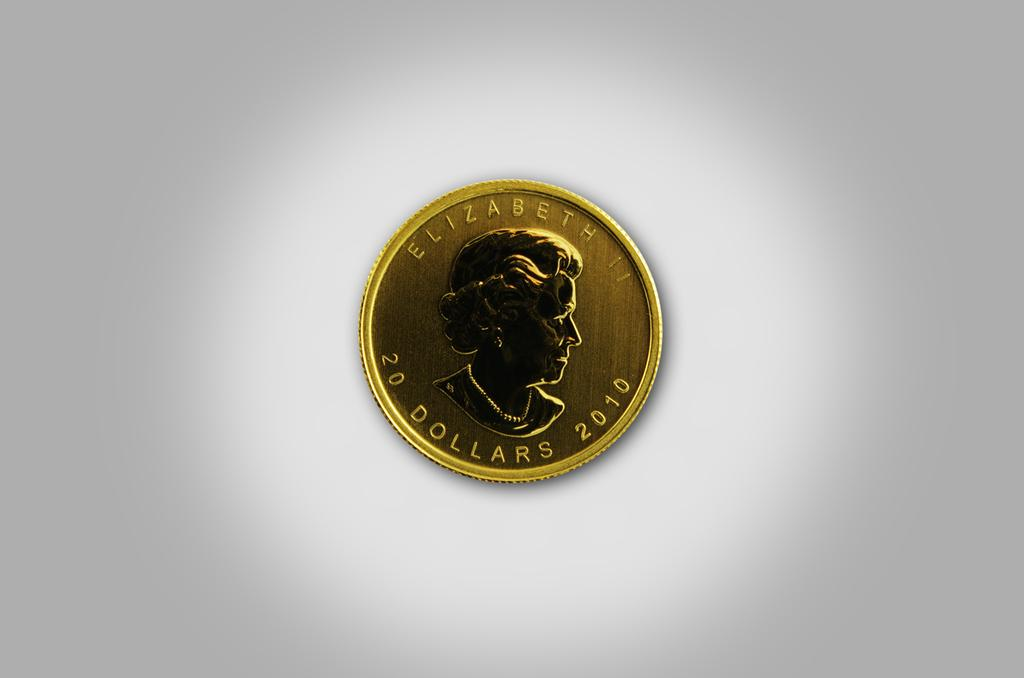<image>
Share a concise interpretation of the image provided. Gold coin that shows Elizabeth and says 20 Dollars 2010 